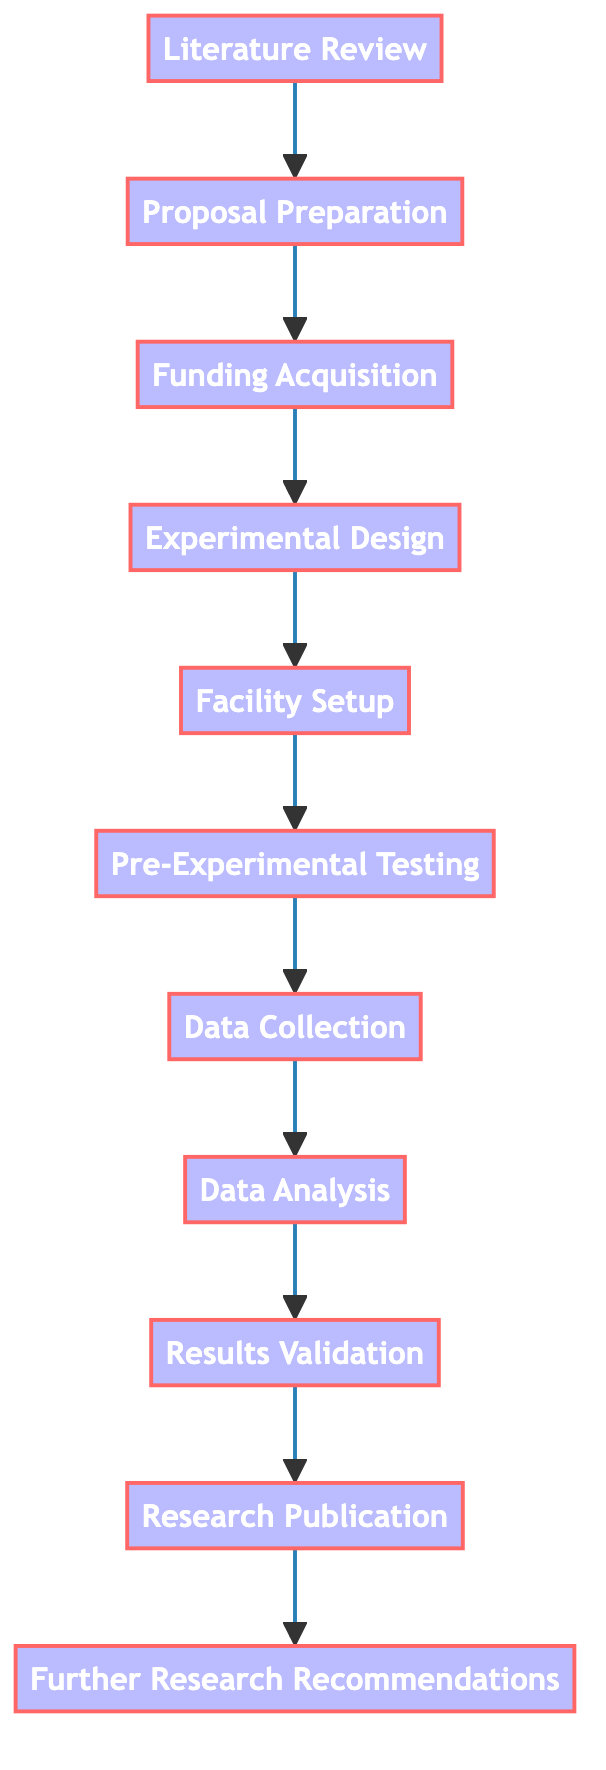What is the first step in the nuclear fusion experiment process? The first step is "Literature Review," as indicated at the top of the flowchart.
Answer: Literature Review How many total steps are there in the process? The flowchart includes eleven distinct steps, starting from "Literature Review" to "Further Research Recommendations."
Answer: 11 What step comes immediately after Funding Acquisition? Following "Funding Acquisition," the next step is "Experimental Design," which is clearly shown in the flow.
Answer: Experimental Design Which step involves securing financial support? The "Funding Acquisition" step is specifically focused on obtaining funding for the experiment, as described in the process.
Answer: Funding Acquisition What is the last step in the process flow? The final step in the flowchart is "Further Research Recommendations," which concludes the experimental process.
Answer: Further Research Recommendations What step involves verifying the correctness of the experimental results? "Results Validation" is the step dedicated to ensuring the accuracy and reliability of the findings by comparing them with theoretical models and past experiments.
Answer: Results Validation List two steps that follow Data Collection. After "Data Collection," the subsequent steps are "Data Analysis" and "Results Validation," which are sequentially connected in the flowchart.
Answer: Data Analysis, Results Validation How many steps precede Facility Setup? Three steps come before "Facility Setup," those being "Literature Review," "Proposal Preparation," and "Funding Acquisition."
Answer: 3 What is the purpose of the Proposal Preparation step? The purpose of "Proposal Preparation" is to prepare a detailed research proposal outlining objectives, methodologies, and expected outcomes for the experiment.
Answer: To prepare a detailed research proposal Which steps focus on data handling? The two steps that focus on data handling are "Data Collection" and "Data Analysis," as they specifically deal with gathering and analyzing data from the experiments.
Answer: Data Collection, Data Analysis 